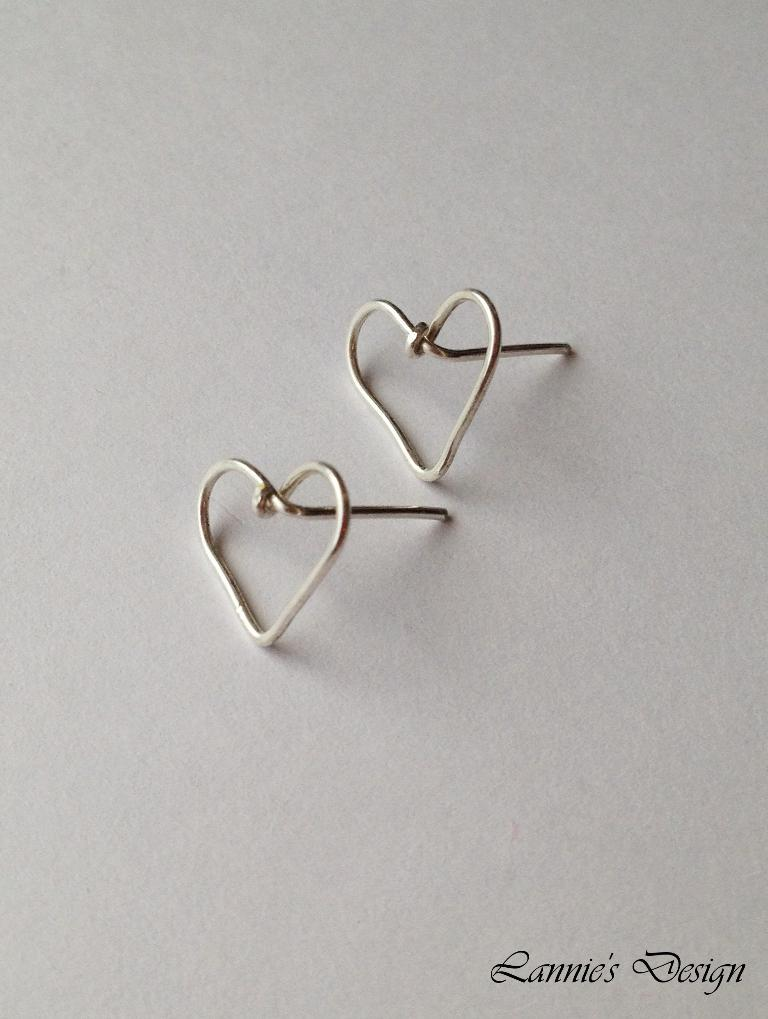What is the primary color of the surface in the image? The primary color of the surface in the image is white. What can be seen on the white surface? There are objects on the white surface in the image. Is there any additional information or marking on the image? Yes, there is a watermark on the bottom right side of the image. Can you tell me how many rivers are flowing through the objects in the image? There are no rivers present in the image; it features objects on a white surface with a watermark. What type of flight is depicted in the image? There is no flight depicted in the image; it only shows objects on a white surface with a watermark. 